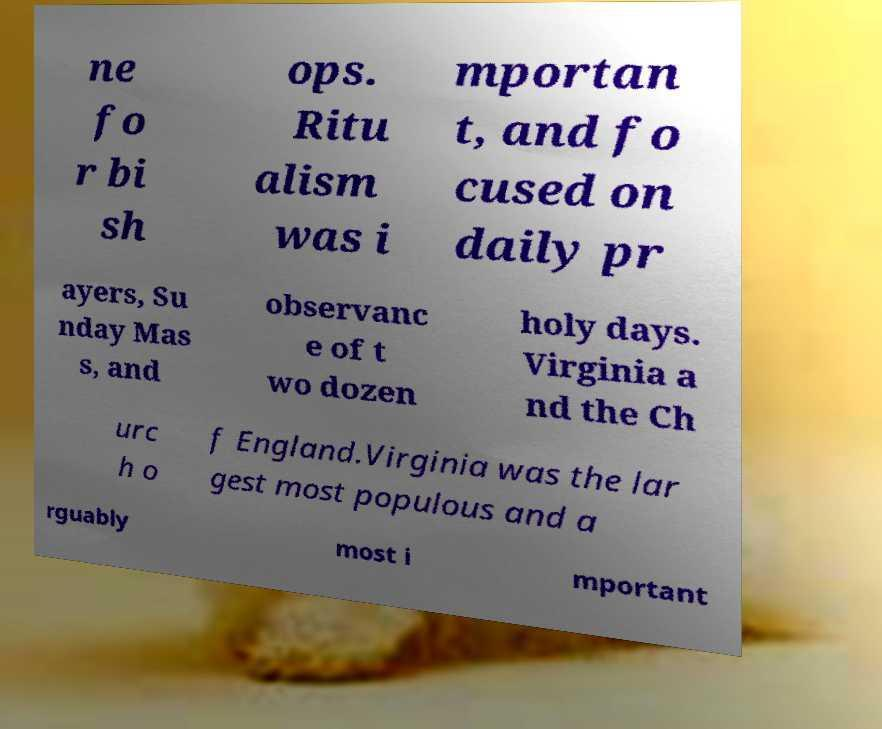I need the written content from this picture converted into text. Can you do that? ne fo r bi sh ops. Ritu alism was i mportan t, and fo cused on daily pr ayers, Su nday Mas s, and observanc e of t wo dozen holy days. Virginia a nd the Ch urc h o f England.Virginia was the lar gest most populous and a rguably most i mportant 